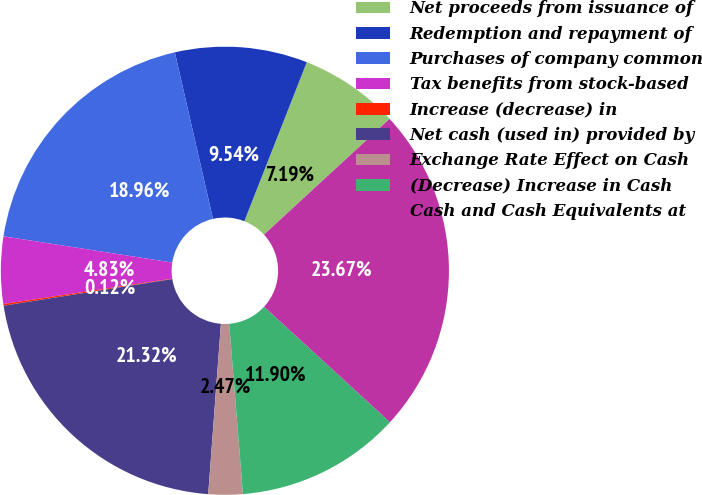<chart> <loc_0><loc_0><loc_500><loc_500><pie_chart><fcel>Net proceeds from issuance of<fcel>Redemption and repayment of<fcel>Purchases of company common<fcel>Tax benefits from stock-based<fcel>Increase (decrease) in<fcel>Net cash (used in) provided by<fcel>Exchange Rate Effect on Cash<fcel>(Decrease) Increase in Cash<fcel>Cash and Cash Equivalents at<nl><fcel>7.19%<fcel>9.54%<fcel>18.96%<fcel>4.83%<fcel>0.12%<fcel>21.32%<fcel>2.47%<fcel>11.9%<fcel>23.67%<nl></chart> 